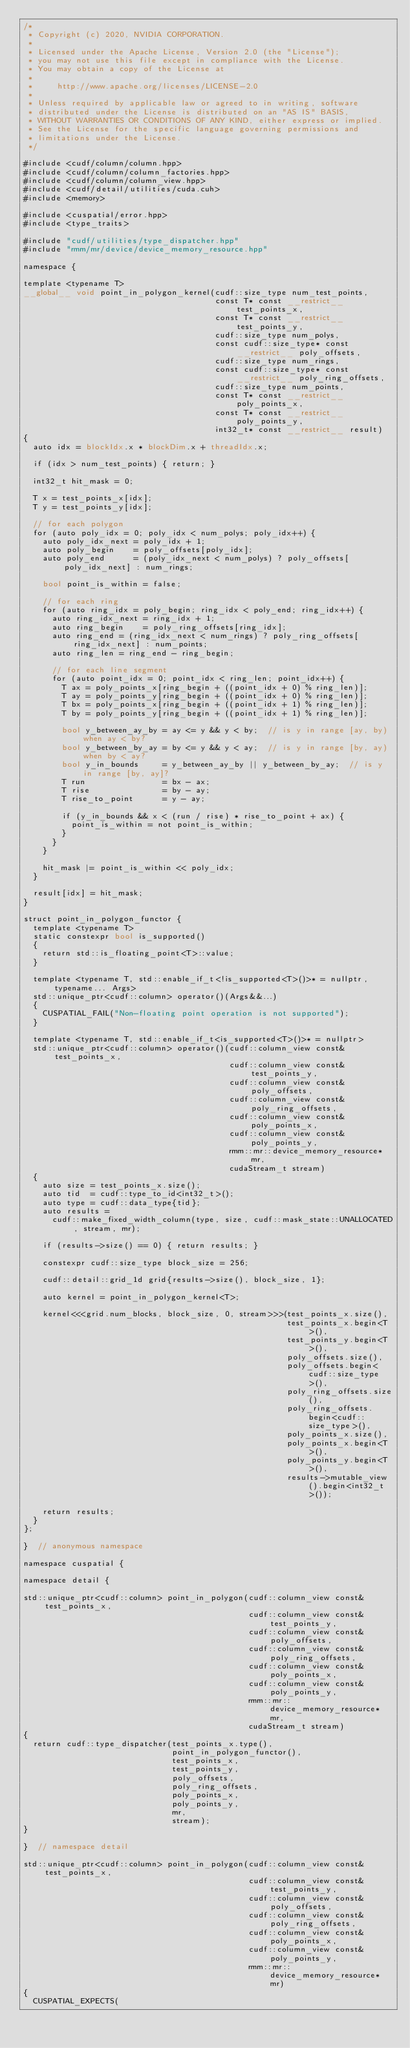<code> <loc_0><loc_0><loc_500><loc_500><_Cuda_>/*
 * Copyright (c) 2020, NVIDIA CORPORATION.
 *
 * Licensed under the Apache License, Version 2.0 (the "License");
 * you may not use this file except in compliance with the License.
 * You may obtain a copy of the License at
 *
 *     http://www.apache.org/licenses/LICENSE-2.0
 *
 * Unless required by applicable law or agreed to in writing, software
 * distributed under the License is distributed on an "AS IS" BASIS,
 * WITHOUT WARRANTIES OR CONDITIONS OF ANY KIND, either express or implied.
 * See the License for the specific language governing permissions and
 * limitations under the License.
 */

#include <cudf/column/column.hpp>
#include <cudf/column/column_factories.hpp>
#include <cudf/column/column_view.hpp>
#include <cudf/detail/utilities/cuda.cuh>
#include <memory>

#include <cuspatial/error.hpp>
#include <type_traits>

#include "cudf/utilities/type_dispatcher.hpp"
#include "rmm/mr/device/device_memory_resource.hpp"

namespace {

template <typename T>
__global__ void point_in_polygon_kernel(cudf::size_type num_test_points,
                                        const T* const __restrict__ test_points_x,
                                        const T* const __restrict__ test_points_y,
                                        cudf::size_type num_polys,
                                        const cudf::size_type* const __restrict__ poly_offsets,
                                        cudf::size_type num_rings,
                                        const cudf::size_type* const __restrict__ poly_ring_offsets,
                                        cudf::size_type num_points,
                                        const T* const __restrict__ poly_points_x,
                                        const T* const __restrict__ poly_points_y,
                                        int32_t* const __restrict__ result)
{
  auto idx = blockIdx.x * blockDim.x + threadIdx.x;

  if (idx > num_test_points) { return; }

  int32_t hit_mask = 0;

  T x = test_points_x[idx];
  T y = test_points_y[idx];

  // for each polygon
  for (auto poly_idx = 0; poly_idx < num_polys; poly_idx++) {
    auto poly_idx_next = poly_idx + 1;
    auto poly_begin    = poly_offsets[poly_idx];
    auto poly_end      = (poly_idx_next < num_polys) ? poly_offsets[poly_idx_next] : num_rings;

    bool point_is_within = false;

    // for each ring
    for (auto ring_idx = poly_begin; ring_idx < poly_end; ring_idx++) {
      auto ring_idx_next = ring_idx + 1;
      auto ring_begin    = poly_ring_offsets[ring_idx];
      auto ring_end = (ring_idx_next < num_rings) ? poly_ring_offsets[ring_idx_next] : num_points;
      auto ring_len = ring_end - ring_begin;

      // for each line segment
      for (auto point_idx = 0; point_idx < ring_len; point_idx++) {
        T ax = poly_points_x[ring_begin + ((point_idx + 0) % ring_len)];
        T ay = poly_points_y[ring_begin + ((point_idx + 0) % ring_len)];
        T bx = poly_points_x[ring_begin + ((point_idx + 1) % ring_len)];
        T by = poly_points_y[ring_begin + ((point_idx + 1) % ring_len)];

        bool y_between_ay_by = ay <= y && y < by;  // is y in range [ay, by) when ay < by?
        bool y_between_by_ay = by <= y && y < ay;  // is y in range [by, ay) when by < ay?
        bool y_in_bounds     = y_between_ay_by || y_between_by_ay;  // is y in range [by, ay]?
        T run                = bx - ax;
        T rise               = by - ay;
        T rise_to_point      = y - ay;

        if (y_in_bounds && x < (run / rise) * rise_to_point + ax) {
          point_is_within = not point_is_within;
        }
      }
    }

    hit_mask |= point_is_within << poly_idx;
  }

  result[idx] = hit_mask;
}

struct point_in_polygon_functor {
  template <typename T>
  static constexpr bool is_supported()
  {
    return std::is_floating_point<T>::value;
  }

  template <typename T, std::enable_if_t<!is_supported<T>()>* = nullptr, typename... Args>
  std::unique_ptr<cudf::column> operator()(Args&&...)
  {
    CUSPATIAL_FAIL("Non-floating point operation is not supported");
  }

  template <typename T, std::enable_if_t<is_supported<T>()>* = nullptr>
  std::unique_ptr<cudf::column> operator()(cudf::column_view const& test_points_x,
                                           cudf::column_view const& test_points_y,
                                           cudf::column_view const& poly_offsets,
                                           cudf::column_view const& poly_ring_offsets,
                                           cudf::column_view const& poly_points_x,
                                           cudf::column_view const& poly_points_y,
                                           rmm::mr::device_memory_resource* mr,
                                           cudaStream_t stream)
  {
    auto size = test_points_x.size();
    auto tid  = cudf::type_to_id<int32_t>();
    auto type = cudf::data_type{tid};
    auto results =
      cudf::make_fixed_width_column(type, size, cudf::mask_state::UNALLOCATED, stream, mr);

    if (results->size() == 0) { return results; }

    constexpr cudf::size_type block_size = 256;

    cudf::detail::grid_1d grid{results->size(), block_size, 1};

    auto kernel = point_in_polygon_kernel<T>;

    kernel<<<grid.num_blocks, block_size, 0, stream>>>(test_points_x.size(),
                                                       test_points_x.begin<T>(),
                                                       test_points_y.begin<T>(),
                                                       poly_offsets.size(),
                                                       poly_offsets.begin<cudf::size_type>(),
                                                       poly_ring_offsets.size(),
                                                       poly_ring_offsets.begin<cudf::size_type>(),
                                                       poly_points_x.size(),
                                                       poly_points_x.begin<T>(),
                                                       poly_points_y.begin<T>(),
                                                       results->mutable_view().begin<int32_t>());

    return results;
  }
};

}  // anonymous namespace

namespace cuspatial {

namespace detail {

std::unique_ptr<cudf::column> point_in_polygon(cudf::column_view const& test_points_x,
                                               cudf::column_view const& test_points_y,
                                               cudf::column_view const& poly_offsets,
                                               cudf::column_view const& poly_ring_offsets,
                                               cudf::column_view const& poly_points_x,
                                               cudf::column_view const& poly_points_y,
                                               rmm::mr::device_memory_resource* mr,
                                               cudaStream_t stream)
{
  return cudf::type_dispatcher(test_points_x.type(),
                               point_in_polygon_functor(),
                               test_points_x,
                               test_points_y,
                               poly_offsets,
                               poly_ring_offsets,
                               poly_points_x,
                               poly_points_y,
                               mr,
                               stream);
}

}  // namespace detail

std::unique_ptr<cudf::column> point_in_polygon(cudf::column_view const& test_points_x,
                                               cudf::column_view const& test_points_y,
                                               cudf::column_view const& poly_offsets,
                                               cudf::column_view const& poly_ring_offsets,
                                               cudf::column_view const& poly_points_x,
                                               cudf::column_view const& poly_points_y,
                                               rmm::mr::device_memory_resource* mr)
{
  CUSPATIAL_EXPECTS(</code> 